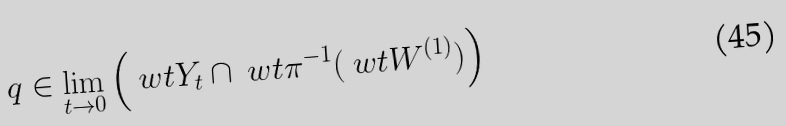<formula> <loc_0><loc_0><loc_500><loc_500>q \in \lim _ { t \to 0 } \left ( \ w t { Y } _ { t } \cap \ w t { \pi } ^ { - 1 } ( \ w t { W } ^ { ( 1 ) } ) \right )</formula> 